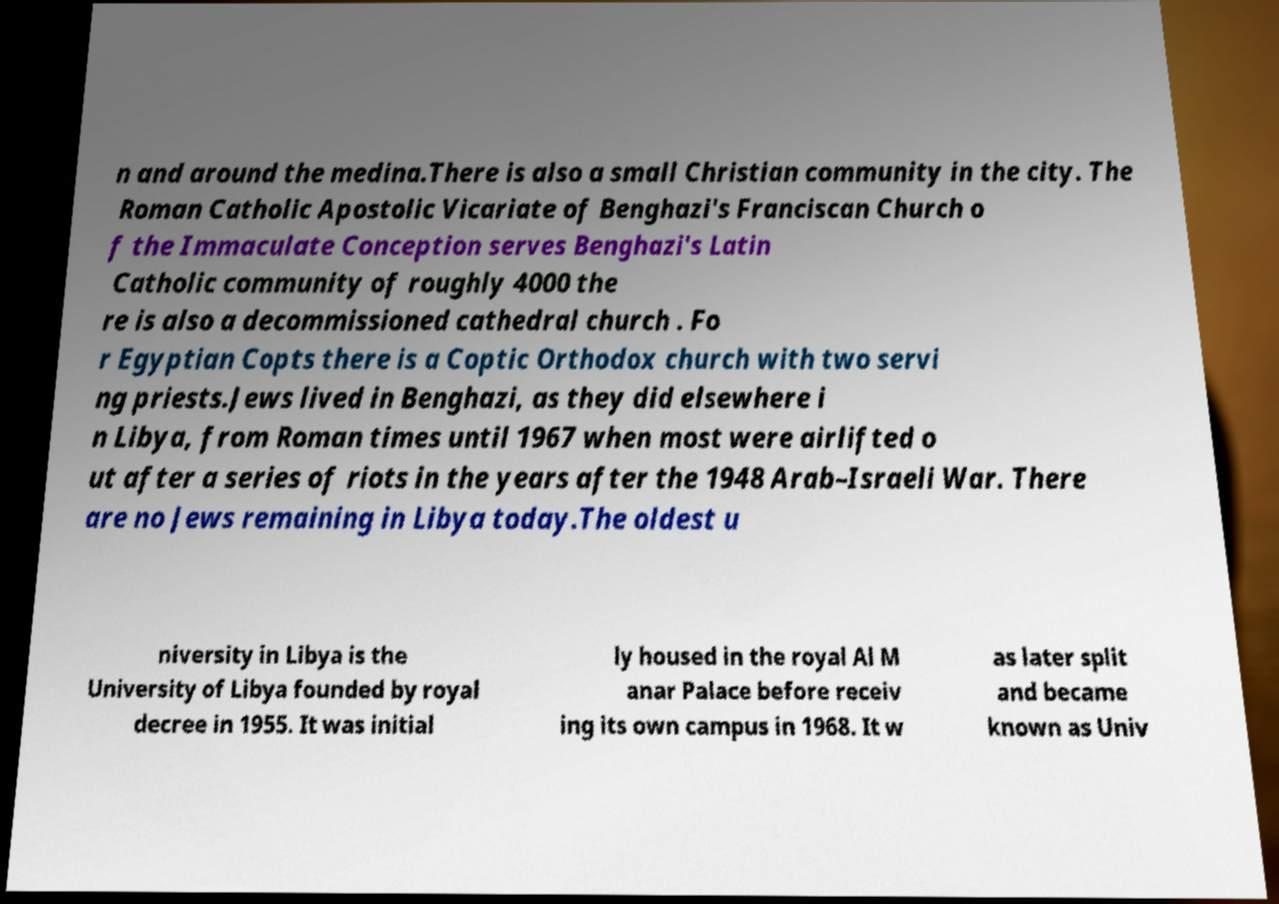Could you assist in decoding the text presented in this image and type it out clearly? n and around the medina.There is also a small Christian community in the city. The Roman Catholic Apostolic Vicariate of Benghazi's Franciscan Church o f the Immaculate Conception serves Benghazi's Latin Catholic community of roughly 4000 the re is also a decommissioned cathedral church . Fo r Egyptian Copts there is a Coptic Orthodox church with two servi ng priests.Jews lived in Benghazi, as they did elsewhere i n Libya, from Roman times until 1967 when most were airlifted o ut after a series of riots in the years after the 1948 Arab–Israeli War. There are no Jews remaining in Libya today.The oldest u niversity in Libya is the University of Libya founded by royal decree in 1955. It was initial ly housed in the royal Al M anar Palace before receiv ing its own campus in 1968. It w as later split and became known as Univ 